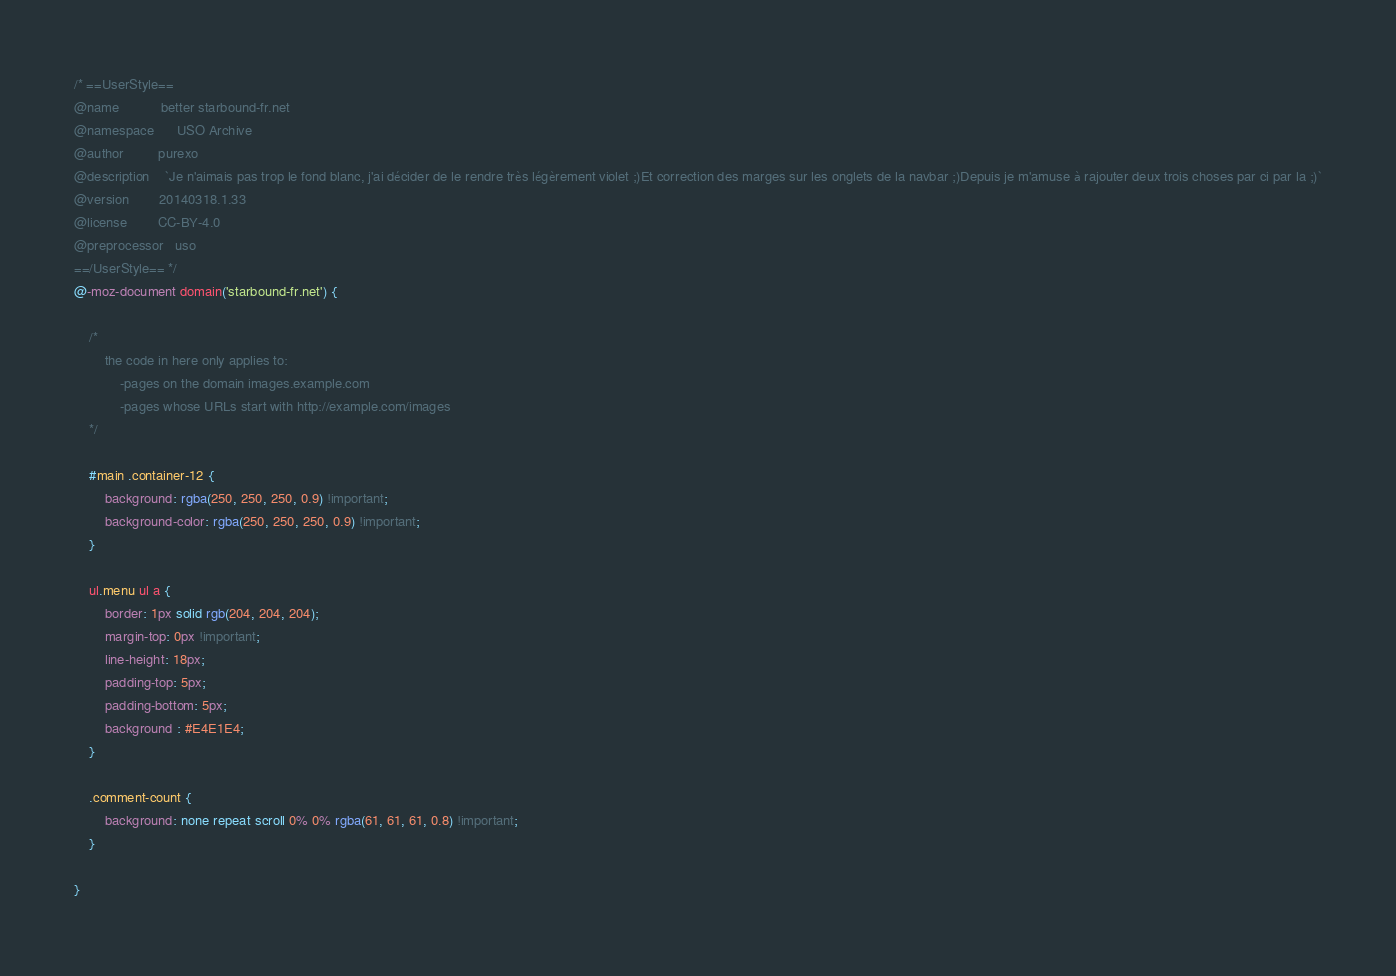Convert code to text. <code><loc_0><loc_0><loc_500><loc_500><_CSS_>/* ==UserStyle==
@name           better starbound-fr.net
@namespace      USO Archive
@author         purexo
@description    `Je n'aimais pas trop le fond blanc, j'ai décider de le rendre très légèrement violet ;)Et correction des marges sur les onglets de la navbar ;)Depuis je m'amuse à rajouter deux trois choses par ci par la ;)`
@version        20140318.1.33
@license        CC-BY-4.0
@preprocessor   uso
==/UserStyle== */
@-moz-document domain('starbound-fr.net') {

	/* 
		the code in here only applies to:
			-pages on the domain images.example.com
			-pages whose URLs start with http://example.com/images
	*/

    #main .container-12 {
        background: rgba(250, 250, 250, 0.9) !important;
        background-color: rgba(250, 250, 250, 0.9) !important;    
    }

    ul.menu ul a {
        border: 1px solid rgb(204, 204, 204);
        margin-top: 0px !important;
        line-height: 18px;
        padding-top: 5px;
        padding-bottom: 5px;
        background : #E4E1E4;
    }

    .comment-count {
        background: none repeat scroll 0% 0% rgba(61, 61, 61, 0.8) !important;
    }

}</code> 